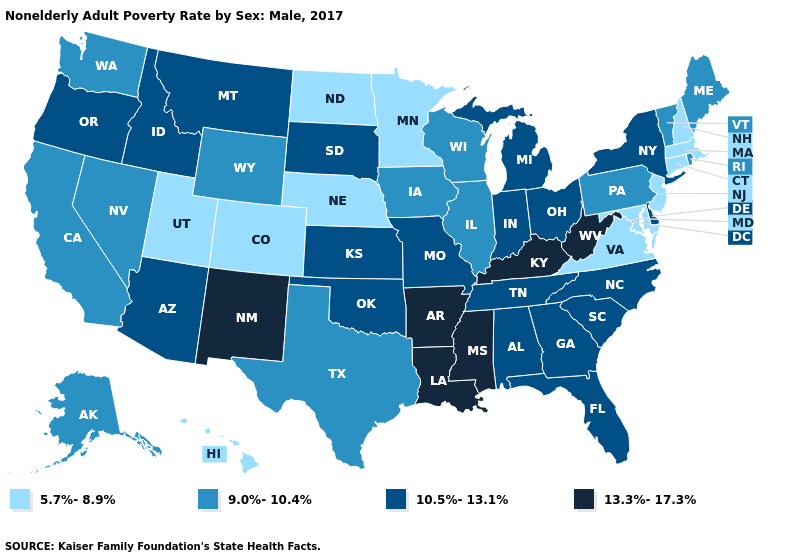Which states have the lowest value in the MidWest?
Be succinct. Minnesota, Nebraska, North Dakota. Which states have the lowest value in the South?
Quick response, please. Maryland, Virginia. What is the value of Florida?
Concise answer only. 10.5%-13.1%. What is the value of Wyoming?
Concise answer only. 9.0%-10.4%. Name the states that have a value in the range 13.3%-17.3%?
Concise answer only. Arkansas, Kentucky, Louisiana, Mississippi, New Mexico, West Virginia. Name the states that have a value in the range 13.3%-17.3%?
Answer briefly. Arkansas, Kentucky, Louisiana, Mississippi, New Mexico, West Virginia. Is the legend a continuous bar?
Concise answer only. No. Does New York have a lower value than Maine?
Give a very brief answer. No. Name the states that have a value in the range 13.3%-17.3%?
Short answer required. Arkansas, Kentucky, Louisiana, Mississippi, New Mexico, West Virginia. Does Mississippi have the highest value in the USA?
Be succinct. Yes. What is the lowest value in the MidWest?
Keep it brief. 5.7%-8.9%. How many symbols are there in the legend?
Quick response, please. 4. Name the states that have a value in the range 9.0%-10.4%?
Quick response, please. Alaska, California, Illinois, Iowa, Maine, Nevada, Pennsylvania, Rhode Island, Texas, Vermont, Washington, Wisconsin, Wyoming. Among the states that border Oregon , does Idaho have the lowest value?
Write a very short answer. No. Name the states that have a value in the range 13.3%-17.3%?
Short answer required. Arkansas, Kentucky, Louisiana, Mississippi, New Mexico, West Virginia. 